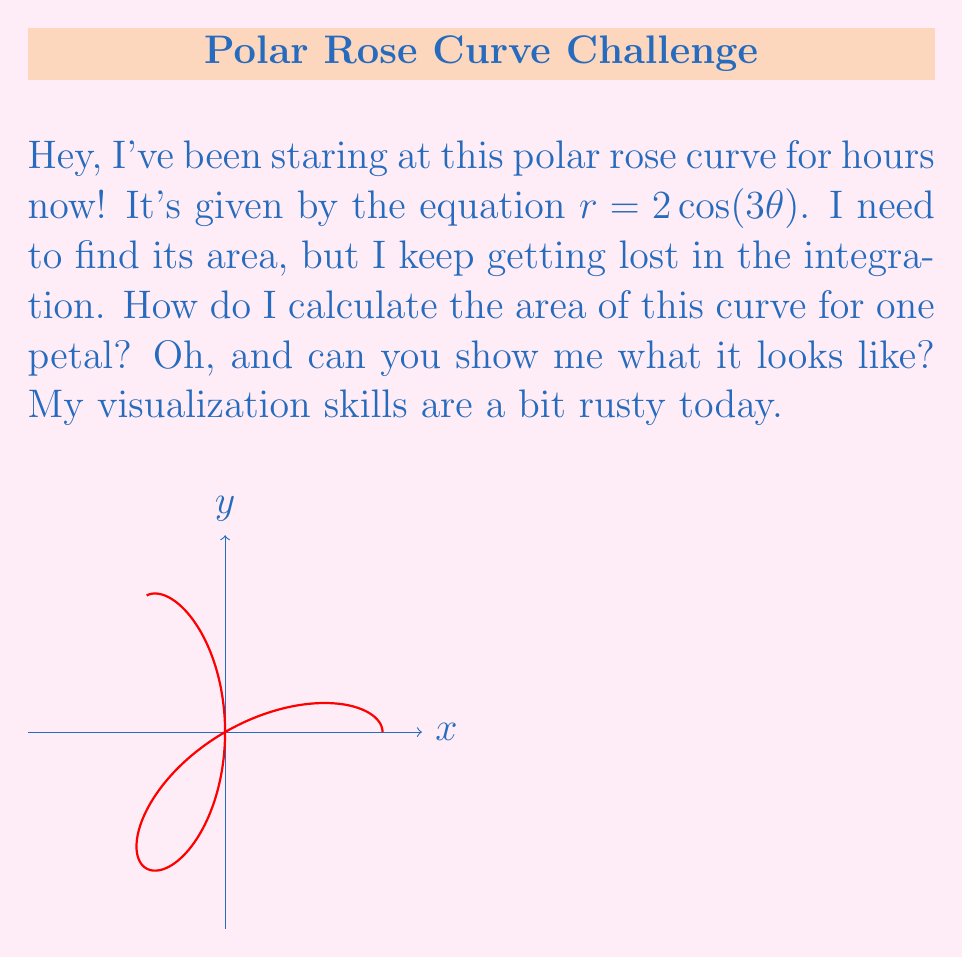Solve this math problem. Alright, let's break this down step-by-step:

1) The area of a polar curve is given by the formula:

   $$A = \frac{1}{2} \int_a^b r^2(\theta) d\theta$$

2) Our curve is $r = 2\cos(3\theta)$, so $r^2 = 4\cos^2(3\theta)$

3) For one petal, we need to integrate from 0 to $\frac{\pi}{3}$ (because $\frac{2\pi}{3}$ gives a full petal)

4) Substituting into our area formula:

   $$A = \frac{1}{2} \int_0^{\pi/3} 4\cos^2(3\theta) d\theta$$

5) Simplify:

   $$A = 2 \int_0^{\pi/3} \cos^2(3\theta) d\theta$$

6) Use the trig identity $\cos^2(x) = \frac{1}{2}(1 + \cos(2x))$:

   $$A = 2 \int_0^{\pi/3} \frac{1}{2}(1 + \cos(6\theta)) d\theta$$
   $$A = \int_0^{\pi/3} (1 + \cos(6\theta)) d\theta$$

7) Integrate:

   $$A = [\theta + \frac{1}{6}\sin(6\theta)]_0^{\pi/3}$$

8) Evaluate:

   $$A = (\frac{\pi}{3} + \frac{1}{6}\sin(2\pi)) - (0 + \frac{1}{6}\sin(0))$$
   $$A = \frac{\pi}{3} + 0 - 0 = \frac{\pi}{3}$$

Therefore, the area of one petal is $\frac{\pi}{3}$.
Answer: $\frac{\pi}{3}$ 